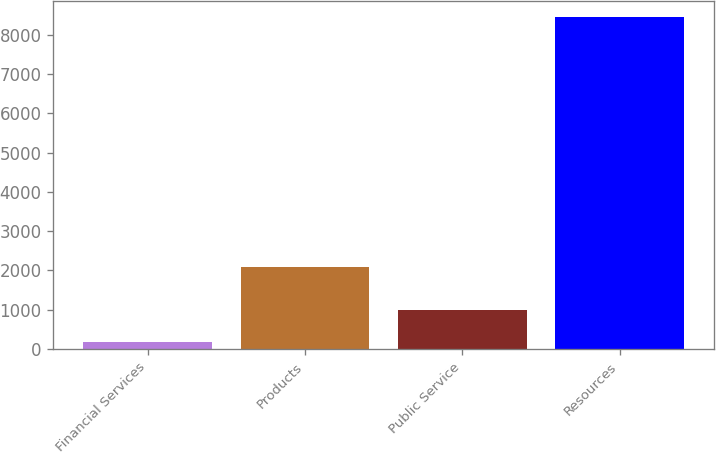Convert chart. <chart><loc_0><loc_0><loc_500><loc_500><bar_chart><fcel>Financial Services<fcel>Products<fcel>Public Service<fcel>Resources<nl><fcel>173<fcel>2090<fcel>1001.2<fcel>8455<nl></chart> 